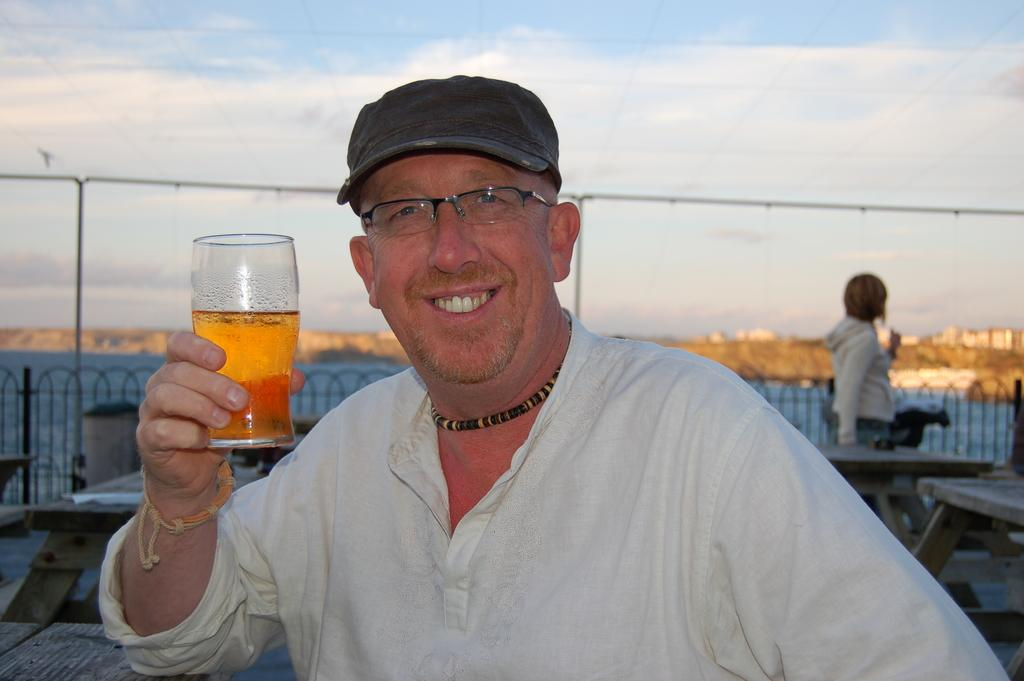Who is present in the image? There is a man in the image. What is the man doing in the image? The man is smiling and holding a glass. What can be seen in the background of the image? There are tables in the background of the image. Are there any other people visible in the image? Yes, there is at least one person in the background of the image. What type of frame surrounds the person in the image? There is no frame surrounding the person in the image; it is a photograph or digital image without a frame. 